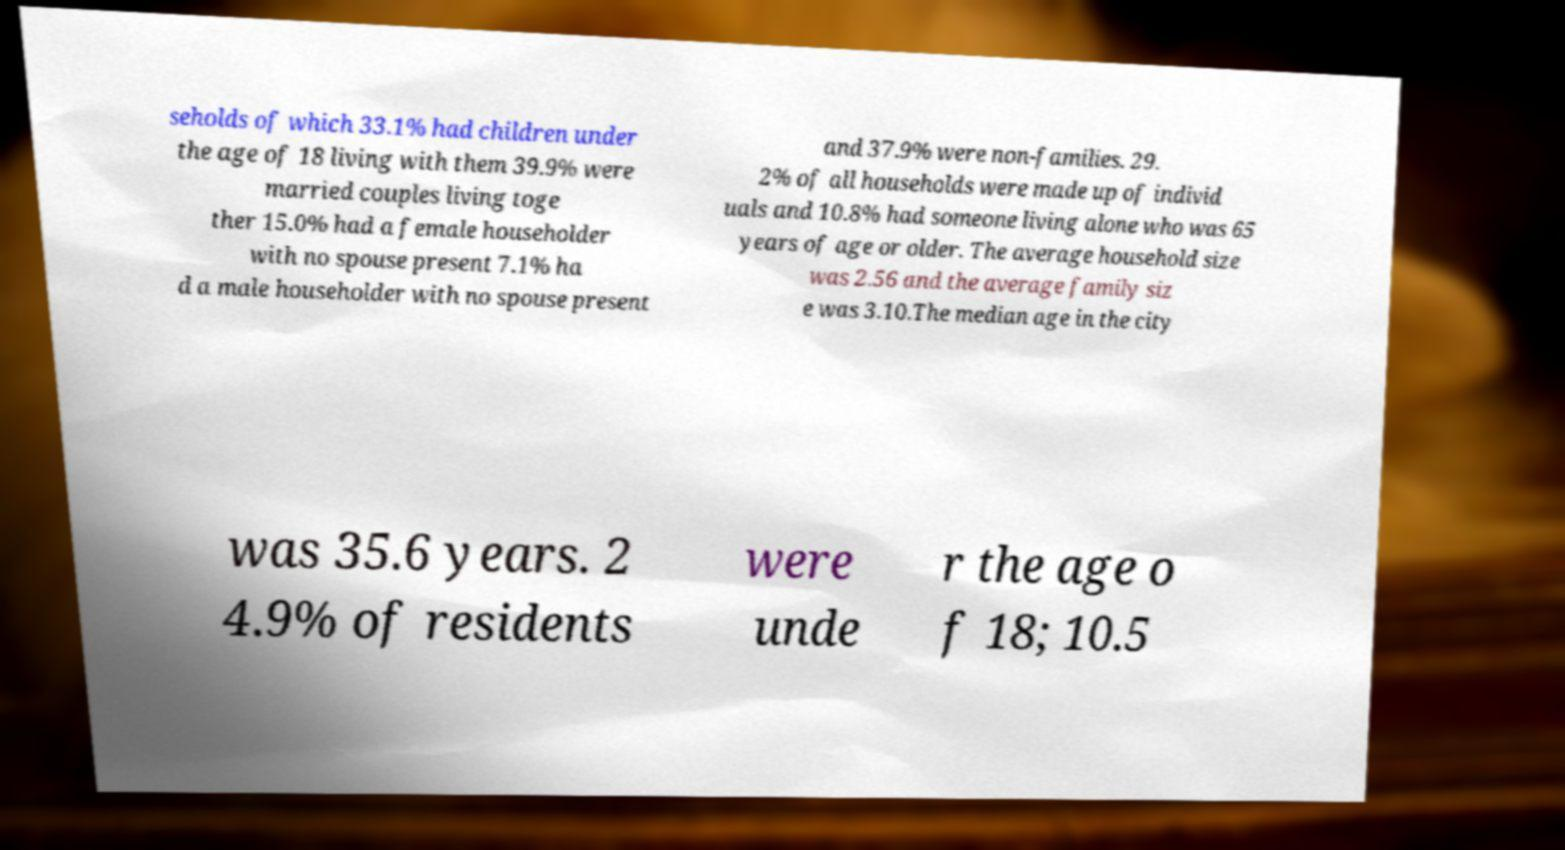Please identify and transcribe the text found in this image. seholds of which 33.1% had children under the age of 18 living with them 39.9% were married couples living toge ther 15.0% had a female householder with no spouse present 7.1% ha d a male householder with no spouse present and 37.9% were non-families. 29. 2% of all households were made up of individ uals and 10.8% had someone living alone who was 65 years of age or older. The average household size was 2.56 and the average family siz e was 3.10.The median age in the city was 35.6 years. 2 4.9% of residents were unde r the age o f 18; 10.5 